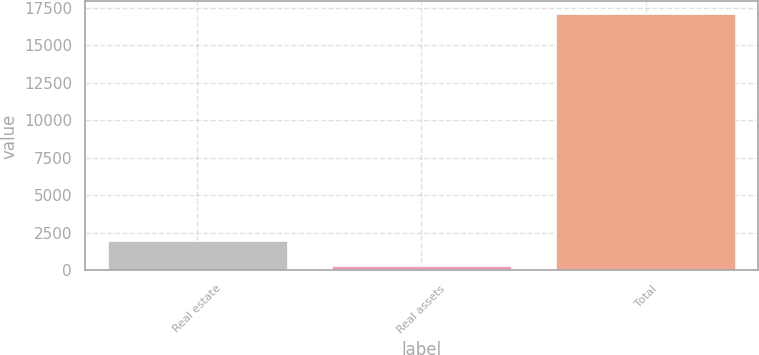Convert chart to OTSL. <chart><loc_0><loc_0><loc_500><loc_500><bar_chart><fcel>Real estate<fcel>Real assets<fcel>Total<nl><fcel>1966.1<fcel>286<fcel>17087<nl></chart> 